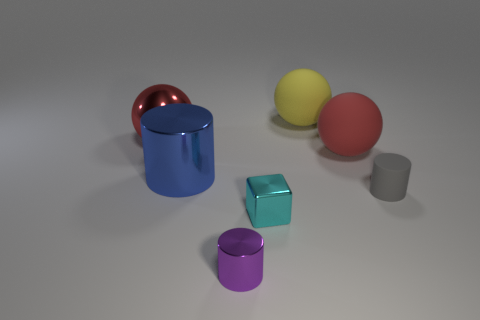Add 1 small purple metal objects. How many objects exist? 8 Subtract all spheres. How many objects are left? 4 Add 1 yellow balls. How many yellow balls are left? 2 Add 2 large gray metal blocks. How many large gray metal blocks exist? 2 Subtract 0 green balls. How many objects are left? 7 Subtract all small purple things. Subtract all gray cylinders. How many objects are left? 5 